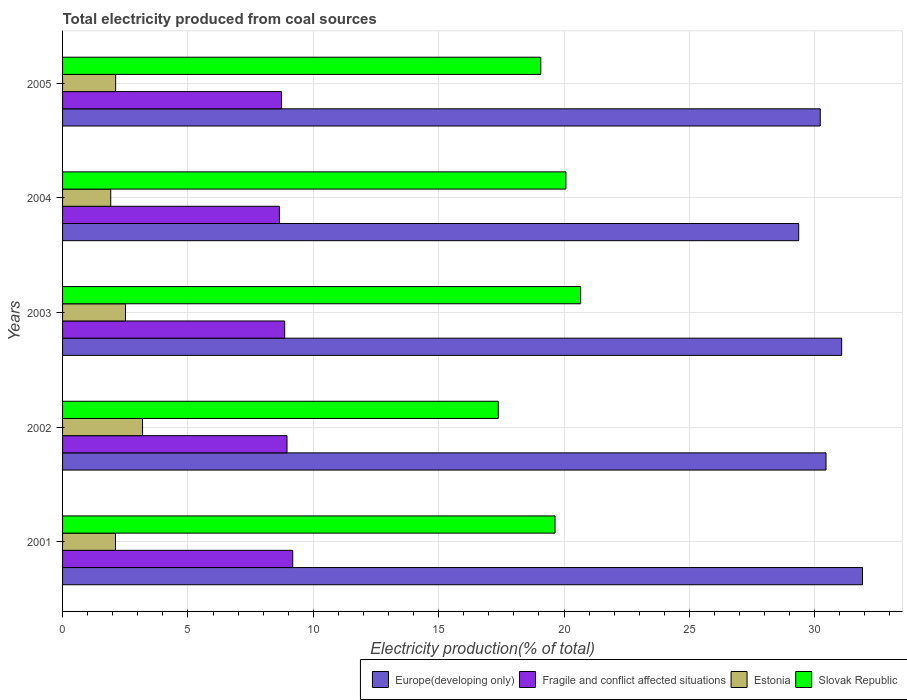How many different coloured bars are there?
Offer a very short reply. 4. How many groups of bars are there?
Ensure brevity in your answer.  5. Are the number of bars per tick equal to the number of legend labels?
Offer a very short reply. Yes. How many bars are there on the 3rd tick from the top?
Your response must be concise. 4. What is the total electricity produced in Slovak Republic in 2005?
Offer a very short reply. 19.07. Across all years, what is the maximum total electricity produced in Fragile and conflict affected situations?
Give a very brief answer. 9.18. Across all years, what is the minimum total electricity produced in Europe(developing only)?
Make the answer very short. 29.36. In which year was the total electricity produced in Estonia maximum?
Keep it short and to the point. 2002. In which year was the total electricity produced in Estonia minimum?
Keep it short and to the point. 2004. What is the total total electricity produced in Slovak Republic in the graph?
Offer a terse response. 96.83. What is the difference between the total electricity produced in Estonia in 2001 and that in 2004?
Provide a short and direct response. 0.19. What is the difference between the total electricity produced in Fragile and conflict affected situations in 2003 and the total electricity produced in Estonia in 2002?
Provide a short and direct response. 5.67. What is the average total electricity produced in Fragile and conflict affected situations per year?
Give a very brief answer. 8.87. In the year 2001, what is the difference between the total electricity produced in Estonia and total electricity produced in Slovak Republic?
Your answer should be compact. -17.53. In how many years, is the total electricity produced in Estonia greater than 29 %?
Your answer should be compact. 0. What is the ratio of the total electricity produced in Slovak Republic in 2004 to that in 2005?
Offer a very short reply. 1.05. Is the difference between the total electricity produced in Estonia in 2002 and 2005 greater than the difference between the total electricity produced in Slovak Republic in 2002 and 2005?
Provide a succinct answer. Yes. What is the difference between the highest and the second highest total electricity produced in Slovak Republic?
Offer a very short reply. 0.59. What is the difference between the highest and the lowest total electricity produced in Slovak Republic?
Offer a terse response. 3.29. Is it the case that in every year, the sum of the total electricity produced in Slovak Republic and total electricity produced in Estonia is greater than the sum of total electricity produced in Fragile and conflict affected situations and total electricity produced in Europe(developing only)?
Your answer should be compact. No. What does the 3rd bar from the top in 2003 represents?
Your answer should be very brief. Fragile and conflict affected situations. What does the 2nd bar from the bottom in 2001 represents?
Provide a succinct answer. Fragile and conflict affected situations. How many bars are there?
Offer a very short reply. 20. Are all the bars in the graph horizontal?
Ensure brevity in your answer.  Yes. Does the graph contain any zero values?
Your answer should be very brief. No. How many legend labels are there?
Offer a very short reply. 4. What is the title of the graph?
Your response must be concise. Total electricity produced from coal sources. What is the label or title of the Y-axis?
Your response must be concise. Years. What is the Electricity production(% of total) in Europe(developing only) in 2001?
Keep it short and to the point. 31.9. What is the Electricity production(% of total) of Fragile and conflict affected situations in 2001?
Your response must be concise. 9.18. What is the Electricity production(% of total) in Estonia in 2001?
Ensure brevity in your answer.  2.11. What is the Electricity production(% of total) of Slovak Republic in 2001?
Your answer should be compact. 19.64. What is the Electricity production(% of total) of Europe(developing only) in 2002?
Ensure brevity in your answer.  30.45. What is the Electricity production(% of total) of Fragile and conflict affected situations in 2002?
Give a very brief answer. 8.95. What is the Electricity production(% of total) in Estonia in 2002?
Make the answer very short. 3.19. What is the Electricity production(% of total) in Slovak Republic in 2002?
Your response must be concise. 17.38. What is the Electricity production(% of total) in Europe(developing only) in 2003?
Give a very brief answer. 31.07. What is the Electricity production(% of total) in Fragile and conflict affected situations in 2003?
Your answer should be very brief. 8.86. What is the Electricity production(% of total) in Estonia in 2003?
Make the answer very short. 2.51. What is the Electricity production(% of total) of Slovak Republic in 2003?
Give a very brief answer. 20.66. What is the Electricity production(% of total) of Europe(developing only) in 2004?
Your answer should be very brief. 29.36. What is the Electricity production(% of total) of Fragile and conflict affected situations in 2004?
Make the answer very short. 8.65. What is the Electricity production(% of total) in Estonia in 2004?
Ensure brevity in your answer.  1.92. What is the Electricity production(% of total) in Slovak Republic in 2004?
Offer a terse response. 20.08. What is the Electricity production(% of total) of Europe(developing only) in 2005?
Make the answer very short. 30.22. What is the Electricity production(% of total) in Fragile and conflict affected situations in 2005?
Offer a very short reply. 8.73. What is the Electricity production(% of total) of Estonia in 2005?
Offer a terse response. 2.12. What is the Electricity production(% of total) of Slovak Republic in 2005?
Provide a succinct answer. 19.07. Across all years, what is the maximum Electricity production(% of total) in Europe(developing only)?
Offer a very short reply. 31.9. Across all years, what is the maximum Electricity production(% of total) in Fragile and conflict affected situations?
Keep it short and to the point. 9.18. Across all years, what is the maximum Electricity production(% of total) in Estonia?
Your response must be concise. 3.19. Across all years, what is the maximum Electricity production(% of total) of Slovak Republic?
Offer a terse response. 20.66. Across all years, what is the minimum Electricity production(% of total) in Europe(developing only)?
Your answer should be very brief. 29.36. Across all years, what is the minimum Electricity production(% of total) of Fragile and conflict affected situations?
Offer a terse response. 8.65. Across all years, what is the minimum Electricity production(% of total) of Estonia?
Provide a succinct answer. 1.92. Across all years, what is the minimum Electricity production(% of total) in Slovak Republic?
Your answer should be compact. 17.38. What is the total Electricity production(% of total) in Europe(developing only) in the graph?
Ensure brevity in your answer.  153. What is the total Electricity production(% of total) of Fragile and conflict affected situations in the graph?
Provide a short and direct response. 44.37. What is the total Electricity production(% of total) of Estonia in the graph?
Provide a short and direct response. 11.85. What is the total Electricity production(% of total) in Slovak Republic in the graph?
Your response must be concise. 96.83. What is the difference between the Electricity production(% of total) in Europe(developing only) in 2001 and that in 2002?
Offer a very short reply. 1.45. What is the difference between the Electricity production(% of total) in Fragile and conflict affected situations in 2001 and that in 2002?
Provide a short and direct response. 0.23. What is the difference between the Electricity production(% of total) of Estonia in 2001 and that in 2002?
Your answer should be very brief. -1.08. What is the difference between the Electricity production(% of total) in Slovak Republic in 2001 and that in 2002?
Your answer should be very brief. 2.26. What is the difference between the Electricity production(% of total) of Europe(developing only) in 2001 and that in 2003?
Ensure brevity in your answer.  0.83. What is the difference between the Electricity production(% of total) in Fragile and conflict affected situations in 2001 and that in 2003?
Your response must be concise. 0.32. What is the difference between the Electricity production(% of total) of Estonia in 2001 and that in 2003?
Offer a terse response. -0.4. What is the difference between the Electricity production(% of total) of Slovak Republic in 2001 and that in 2003?
Provide a succinct answer. -1.02. What is the difference between the Electricity production(% of total) of Europe(developing only) in 2001 and that in 2004?
Make the answer very short. 2.54. What is the difference between the Electricity production(% of total) in Fragile and conflict affected situations in 2001 and that in 2004?
Your answer should be compact. 0.53. What is the difference between the Electricity production(% of total) of Estonia in 2001 and that in 2004?
Provide a short and direct response. 0.19. What is the difference between the Electricity production(% of total) in Slovak Republic in 2001 and that in 2004?
Give a very brief answer. -0.43. What is the difference between the Electricity production(% of total) in Europe(developing only) in 2001 and that in 2005?
Your answer should be very brief. 1.68. What is the difference between the Electricity production(% of total) in Fragile and conflict affected situations in 2001 and that in 2005?
Ensure brevity in your answer.  0.45. What is the difference between the Electricity production(% of total) in Estonia in 2001 and that in 2005?
Your response must be concise. -0.01. What is the difference between the Electricity production(% of total) of Slovak Republic in 2001 and that in 2005?
Offer a terse response. 0.57. What is the difference between the Electricity production(% of total) of Europe(developing only) in 2002 and that in 2003?
Provide a short and direct response. -0.62. What is the difference between the Electricity production(% of total) of Fragile and conflict affected situations in 2002 and that in 2003?
Ensure brevity in your answer.  0.09. What is the difference between the Electricity production(% of total) in Estonia in 2002 and that in 2003?
Keep it short and to the point. 0.68. What is the difference between the Electricity production(% of total) in Slovak Republic in 2002 and that in 2003?
Your answer should be compact. -3.29. What is the difference between the Electricity production(% of total) in Europe(developing only) in 2002 and that in 2004?
Offer a very short reply. 1.09. What is the difference between the Electricity production(% of total) of Fragile and conflict affected situations in 2002 and that in 2004?
Ensure brevity in your answer.  0.3. What is the difference between the Electricity production(% of total) of Estonia in 2002 and that in 2004?
Offer a very short reply. 1.27. What is the difference between the Electricity production(% of total) in Slovak Republic in 2002 and that in 2004?
Offer a very short reply. -2.7. What is the difference between the Electricity production(% of total) in Europe(developing only) in 2002 and that in 2005?
Provide a short and direct response. 0.23. What is the difference between the Electricity production(% of total) in Fragile and conflict affected situations in 2002 and that in 2005?
Your answer should be very brief. 0.22. What is the difference between the Electricity production(% of total) of Estonia in 2002 and that in 2005?
Keep it short and to the point. 1.07. What is the difference between the Electricity production(% of total) of Slovak Republic in 2002 and that in 2005?
Provide a succinct answer. -1.7. What is the difference between the Electricity production(% of total) in Europe(developing only) in 2003 and that in 2004?
Offer a very short reply. 1.71. What is the difference between the Electricity production(% of total) in Fragile and conflict affected situations in 2003 and that in 2004?
Offer a very short reply. 0.21. What is the difference between the Electricity production(% of total) in Estonia in 2003 and that in 2004?
Your response must be concise. 0.59. What is the difference between the Electricity production(% of total) of Slovak Republic in 2003 and that in 2004?
Your answer should be compact. 0.59. What is the difference between the Electricity production(% of total) in Europe(developing only) in 2003 and that in 2005?
Ensure brevity in your answer.  0.85. What is the difference between the Electricity production(% of total) in Fragile and conflict affected situations in 2003 and that in 2005?
Offer a very short reply. 0.13. What is the difference between the Electricity production(% of total) of Estonia in 2003 and that in 2005?
Keep it short and to the point. 0.39. What is the difference between the Electricity production(% of total) in Slovak Republic in 2003 and that in 2005?
Give a very brief answer. 1.59. What is the difference between the Electricity production(% of total) of Europe(developing only) in 2004 and that in 2005?
Provide a succinct answer. -0.86. What is the difference between the Electricity production(% of total) in Fragile and conflict affected situations in 2004 and that in 2005?
Offer a very short reply. -0.08. What is the difference between the Electricity production(% of total) in Estonia in 2004 and that in 2005?
Give a very brief answer. -0.2. What is the difference between the Electricity production(% of total) of Europe(developing only) in 2001 and the Electricity production(% of total) of Fragile and conflict affected situations in 2002?
Give a very brief answer. 22.95. What is the difference between the Electricity production(% of total) in Europe(developing only) in 2001 and the Electricity production(% of total) in Estonia in 2002?
Ensure brevity in your answer.  28.71. What is the difference between the Electricity production(% of total) in Europe(developing only) in 2001 and the Electricity production(% of total) in Slovak Republic in 2002?
Make the answer very short. 14.53. What is the difference between the Electricity production(% of total) in Fragile and conflict affected situations in 2001 and the Electricity production(% of total) in Estonia in 2002?
Ensure brevity in your answer.  5.99. What is the difference between the Electricity production(% of total) of Fragile and conflict affected situations in 2001 and the Electricity production(% of total) of Slovak Republic in 2002?
Your response must be concise. -8.2. What is the difference between the Electricity production(% of total) of Estonia in 2001 and the Electricity production(% of total) of Slovak Republic in 2002?
Provide a short and direct response. -15.27. What is the difference between the Electricity production(% of total) of Europe(developing only) in 2001 and the Electricity production(% of total) of Fragile and conflict affected situations in 2003?
Ensure brevity in your answer.  23.04. What is the difference between the Electricity production(% of total) of Europe(developing only) in 2001 and the Electricity production(% of total) of Estonia in 2003?
Provide a short and direct response. 29.39. What is the difference between the Electricity production(% of total) of Europe(developing only) in 2001 and the Electricity production(% of total) of Slovak Republic in 2003?
Give a very brief answer. 11.24. What is the difference between the Electricity production(% of total) of Fragile and conflict affected situations in 2001 and the Electricity production(% of total) of Estonia in 2003?
Offer a terse response. 6.67. What is the difference between the Electricity production(% of total) of Fragile and conflict affected situations in 2001 and the Electricity production(% of total) of Slovak Republic in 2003?
Give a very brief answer. -11.48. What is the difference between the Electricity production(% of total) of Estonia in 2001 and the Electricity production(% of total) of Slovak Republic in 2003?
Provide a succinct answer. -18.55. What is the difference between the Electricity production(% of total) in Europe(developing only) in 2001 and the Electricity production(% of total) in Fragile and conflict affected situations in 2004?
Your answer should be compact. 23.26. What is the difference between the Electricity production(% of total) in Europe(developing only) in 2001 and the Electricity production(% of total) in Estonia in 2004?
Offer a terse response. 29.98. What is the difference between the Electricity production(% of total) of Europe(developing only) in 2001 and the Electricity production(% of total) of Slovak Republic in 2004?
Your response must be concise. 11.83. What is the difference between the Electricity production(% of total) in Fragile and conflict affected situations in 2001 and the Electricity production(% of total) in Estonia in 2004?
Provide a succinct answer. 7.26. What is the difference between the Electricity production(% of total) in Fragile and conflict affected situations in 2001 and the Electricity production(% of total) in Slovak Republic in 2004?
Ensure brevity in your answer.  -10.9. What is the difference between the Electricity production(% of total) in Estonia in 2001 and the Electricity production(% of total) in Slovak Republic in 2004?
Make the answer very short. -17.97. What is the difference between the Electricity production(% of total) of Europe(developing only) in 2001 and the Electricity production(% of total) of Fragile and conflict affected situations in 2005?
Give a very brief answer. 23.17. What is the difference between the Electricity production(% of total) in Europe(developing only) in 2001 and the Electricity production(% of total) in Estonia in 2005?
Provide a short and direct response. 29.79. What is the difference between the Electricity production(% of total) of Europe(developing only) in 2001 and the Electricity production(% of total) of Slovak Republic in 2005?
Give a very brief answer. 12.83. What is the difference between the Electricity production(% of total) in Fragile and conflict affected situations in 2001 and the Electricity production(% of total) in Estonia in 2005?
Ensure brevity in your answer.  7.06. What is the difference between the Electricity production(% of total) of Fragile and conflict affected situations in 2001 and the Electricity production(% of total) of Slovak Republic in 2005?
Keep it short and to the point. -9.89. What is the difference between the Electricity production(% of total) of Estonia in 2001 and the Electricity production(% of total) of Slovak Republic in 2005?
Offer a terse response. -16.96. What is the difference between the Electricity production(% of total) of Europe(developing only) in 2002 and the Electricity production(% of total) of Fragile and conflict affected situations in 2003?
Your answer should be compact. 21.59. What is the difference between the Electricity production(% of total) in Europe(developing only) in 2002 and the Electricity production(% of total) in Estonia in 2003?
Make the answer very short. 27.94. What is the difference between the Electricity production(% of total) in Europe(developing only) in 2002 and the Electricity production(% of total) in Slovak Republic in 2003?
Your answer should be compact. 9.79. What is the difference between the Electricity production(% of total) in Fragile and conflict affected situations in 2002 and the Electricity production(% of total) in Estonia in 2003?
Your answer should be very brief. 6.44. What is the difference between the Electricity production(% of total) in Fragile and conflict affected situations in 2002 and the Electricity production(% of total) in Slovak Republic in 2003?
Make the answer very short. -11.71. What is the difference between the Electricity production(% of total) in Estonia in 2002 and the Electricity production(% of total) in Slovak Republic in 2003?
Offer a very short reply. -17.47. What is the difference between the Electricity production(% of total) of Europe(developing only) in 2002 and the Electricity production(% of total) of Fragile and conflict affected situations in 2004?
Ensure brevity in your answer.  21.8. What is the difference between the Electricity production(% of total) of Europe(developing only) in 2002 and the Electricity production(% of total) of Estonia in 2004?
Your answer should be compact. 28.53. What is the difference between the Electricity production(% of total) in Europe(developing only) in 2002 and the Electricity production(% of total) in Slovak Republic in 2004?
Your answer should be compact. 10.37. What is the difference between the Electricity production(% of total) in Fragile and conflict affected situations in 2002 and the Electricity production(% of total) in Estonia in 2004?
Make the answer very short. 7.03. What is the difference between the Electricity production(% of total) of Fragile and conflict affected situations in 2002 and the Electricity production(% of total) of Slovak Republic in 2004?
Provide a short and direct response. -11.12. What is the difference between the Electricity production(% of total) in Estonia in 2002 and the Electricity production(% of total) in Slovak Republic in 2004?
Your answer should be compact. -16.89. What is the difference between the Electricity production(% of total) of Europe(developing only) in 2002 and the Electricity production(% of total) of Fragile and conflict affected situations in 2005?
Give a very brief answer. 21.72. What is the difference between the Electricity production(% of total) in Europe(developing only) in 2002 and the Electricity production(% of total) in Estonia in 2005?
Keep it short and to the point. 28.33. What is the difference between the Electricity production(% of total) of Europe(developing only) in 2002 and the Electricity production(% of total) of Slovak Republic in 2005?
Offer a terse response. 11.38. What is the difference between the Electricity production(% of total) in Fragile and conflict affected situations in 2002 and the Electricity production(% of total) in Estonia in 2005?
Offer a very short reply. 6.83. What is the difference between the Electricity production(% of total) in Fragile and conflict affected situations in 2002 and the Electricity production(% of total) in Slovak Republic in 2005?
Offer a terse response. -10.12. What is the difference between the Electricity production(% of total) of Estonia in 2002 and the Electricity production(% of total) of Slovak Republic in 2005?
Offer a terse response. -15.88. What is the difference between the Electricity production(% of total) of Europe(developing only) in 2003 and the Electricity production(% of total) of Fragile and conflict affected situations in 2004?
Ensure brevity in your answer.  22.42. What is the difference between the Electricity production(% of total) of Europe(developing only) in 2003 and the Electricity production(% of total) of Estonia in 2004?
Keep it short and to the point. 29.15. What is the difference between the Electricity production(% of total) of Europe(developing only) in 2003 and the Electricity production(% of total) of Slovak Republic in 2004?
Your answer should be compact. 11. What is the difference between the Electricity production(% of total) in Fragile and conflict affected situations in 2003 and the Electricity production(% of total) in Estonia in 2004?
Offer a very short reply. 6.94. What is the difference between the Electricity production(% of total) of Fragile and conflict affected situations in 2003 and the Electricity production(% of total) of Slovak Republic in 2004?
Make the answer very short. -11.22. What is the difference between the Electricity production(% of total) in Estonia in 2003 and the Electricity production(% of total) in Slovak Republic in 2004?
Ensure brevity in your answer.  -17.57. What is the difference between the Electricity production(% of total) of Europe(developing only) in 2003 and the Electricity production(% of total) of Fragile and conflict affected situations in 2005?
Offer a very short reply. 22.34. What is the difference between the Electricity production(% of total) in Europe(developing only) in 2003 and the Electricity production(% of total) in Estonia in 2005?
Provide a succinct answer. 28.96. What is the difference between the Electricity production(% of total) in Europe(developing only) in 2003 and the Electricity production(% of total) in Slovak Republic in 2005?
Offer a terse response. 12. What is the difference between the Electricity production(% of total) of Fragile and conflict affected situations in 2003 and the Electricity production(% of total) of Estonia in 2005?
Make the answer very short. 6.74. What is the difference between the Electricity production(% of total) in Fragile and conflict affected situations in 2003 and the Electricity production(% of total) in Slovak Republic in 2005?
Make the answer very short. -10.21. What is the difference between the Electricity production(% of total) in Estonia in 2003 and the Electricity production(% of total) in Slovak Republic in 2005?
Ensure brevity in your answer.  -16.56. What is the difference between the Electricity production(% of total) of Europe(developing only) in 2004 and the Electricity production(% of total) of Fragile and conflict affected situations in 2005?
Give a very brief answer. 20.63. What is the difference between the Electricity production(% of total) in Europe(developing only) in 2004 and the Electricity production(% of total) in Estonia in 2005?
Your answer should be very brief. 27.24. What is the difference between the Electricity production(% of total) of Europe(developing only) in 2004 and the Electricity production(% of total) of Slovak Republic in 2005?
Your answer should be very brief. 10.29. What is the difference between the Electricity production(% of total) of Fragile and conflict affected situations in 2004 and the Electricity production(% of total) of Estonia in 2005?
Keep it short and to the point. 6.53. What is the difference between the Electricity production(% of total) of Fragile and conflict affected situations in 2004 and the Electricity production(% of total) of Slovak Republic in 2005?
Keep it short and to the point. -10.43. What is the difference between the Electricity production(% of total) in Estonia in 2004 and the Electricity production(% of total) in Slovak Republic in 2005?
Give a very brief answer. -17.15. What is the average Electricity production(% of total) in Europe(developing only) per year?
Keep it short and to the point. 30.6. What is the average Electricity production(% of total) in Fragile and conflict affected situations per year?
Provide a succinct answer. 8.87. What is the average Electricity production(% of total) of Estonia per year?
Offer a terse response. 2.37. What is the average Electricity production(% of total) of Slovak Republic per year?
Offer a terse response. 19.37. In the year 2001, what is the difference between the Electricity production(% of total) of Europe(developing only) and Electricity production(% of total) of Fragile and conflict affected situations?
Give a very brief answer. 22.72. In the year 2001, what is the difference between the Electricity production(% of total) in Europe(developing only) and Electricity production(% of total) in Estonia?
Offer a very short reply. 29.79. In the year 2001, what is the difference between the Electricity production(% of total) of Europe(developing only) and Electricity production(% of total) of Slovak Republic?
Give a very brief answer. 12.26. In the year 2001, what is the difference between the Electricity production(% of total) in Fragile and conflict affected situations and Electricity production(% of total) in Estonia?
Keep it short and to the point. 7.07. In the year 2001, what is the difference between the Electricity production(% of total) in Fragile and conflict affected situations and Electricity production(% of total) in Slovak Republic?
Ensure brevity in your answer.  -10.46. In the year 2001, what is the difference between the Electricity production(% of total) of Estonia and Electricity production(% of total) of Slovak Republic?
Your answer should be compact. -17.53. In the year 2002, what is the difference between the Electricity production(% of total) in Europe(developing only) and Electricity production(% of total) in Fragile and conflict affected situations?
Ensure brevity in your answer.  21.5. In the year 2002, what is the difference between the Electricity production(% of total) in Europe(developing only) and Electricity production(% of total) in Estonia?
Your answer should be compact. 27.26. In the year 2002, what is the difference between the Electricity production(% of total) in Europe(developing only) and Electricity production(% of total) in Slovak Republic?
Ensure brevity in your answer.  13.07. In the year 2002, what is the difference between the Electricity production(% of total) of Fragile and conflict affected situations and Electricity production(% of total) of Estonia?
Ensure brevity in your answer.  5.76. In the year 2002, what is the difference between the Electricity production(% of total) in Fragile and conflict affected situations and Electricity production(% of total) in Slovak Republic?
Your answer should be compact. -8.43. In the year 2002, what is the difference between the Electricity production(% of total) of Estonia and Electricity production(% of total) of Slovak Republic?
Provide a short and direct response. -14.19. In the year 2003, what is the difference between the Electricity production(% of total) in Europe(developing only) and Electricity production(% of total) in Fragile and conflict affected situations?
Offer a terse response. 22.21. In the year 2003, what is the difference between the Electricity production(% of total) in Europe(developing only) and Electricity production(% of total) in Estonia?
Offer a very short reply. 28.56. In the year 2003, what is the difference between the Electricity production(% of total) of Europe(developing only) and Electricity production(% of total) of Slovak Republic?
Your answer should be very brief. 10.41. In the year 2003, what is the difference between the Electricity production(% of total) of Fragile and conflict affected situations and Electricity production(% of total) of Estonia?
Your answer should be compact. 6.35. In the year 2003, what is the difference between the Electricity production(% of total) of Fragile and conflict affected situations and Electricity production(% of total) of Slovak Republic?
Offer a terse response. -11.8. In the year 2003, what is the difference between the Electricity production(% of total) in Estonia and Electricity production(% of total) in Slovak Republic?
Provide a short and direct response. -18.15. In the year 2004, what is the difference between the Electricity production(% of total) of Europe(developing only) and Electricity production(% of total) of Fragile and conflict affected situations?
Give a very brief answer. 20.71. In the year 2004, what is the difference between the Electricity production(% of total) in Europe(developing only) and Electricity production(% of total) in Estonia?
Ensure brevity in your answer.  27.44. In the year 2004, what is the difference between the Electricity production(% of total) in Europe(developing only) and Electricity production(% of total) in Slovak Republic?
Provide a succinct answer. 9.28. In the year 2004, what is the difference between the Electricity production(% of total) of Fragile and conflict affected situations and Electricity production(% of total) of Estonia?
Give a very brief answer. 6.73. In the year 2004, what is the difference between the Electricity production(% of total) in Fragile and conflict affected situations and Electricity production(% of total) in Slovak Republic?
Ensure brevity in your answer.  -11.43. In the year 2004, what is the difference between the Electricity production(% of total) in Estonia and Electricity production(% of total) in Slovak Republic?
Your response must be concise. -18.15. In the year 2005, what is the difference between the Electricity production(% of total) of Europe(developing only) and Electricity production(% of total) of Fragile and conflict affected situations?
Your answer should be compact. 21.49. In the year 2005, what is the difference between the Electricity production(% of total) in Europe(developing only) and Electricity production(% of total) in Estonia?
Your answer should be very brief. 28.1. In the year 2005, what is the difference between the Electricity production(% of total) in Europe(developing only) and Electricity production(% of total) in Slovak Republic?
Your answer should be compact. 11.15. In the year 2005, what is the difference between the Electricity production(% of total) of Fragile and conflict affected situations and Electricity production(% of total) of Estonia?
Provide a short and direct response. 6.62. In the year 2005, what is the difference between the Electricity production(% of total) in Fragile and conflict affected situations and Electricity production(% of total) in Slovak Republic?
Offer a terse response. -10.34. In the year 2005, what is the difference between the Electricity production(% of total) in Estonia and Electricity production(% of total) in Slovak Republic?
Offer a terse response. -16.96. What is the ratio of the Electricity production(% of total) in Europe(developing only) in 2001 to that in 2002?
Keep it short and to the point. 1.05. What is the ratio of the Electricity production(% of total) of Fragile and conflict affected situations in 2001 to that in 2002?
Your answer should be compact. 1.03. What is the ratio of the Electricity production(% of total) in Estonia in 2001 to that in 2002?
Your answer should be compact. 0.66. What is the ratio of the Electricity production(% of total) in Slovak Republic in 2001 to that in 2002?
Provide a succinct answer. 1.13. What is the ratio of the Electricity production(% of total) in Europe(developing only) in 2001 to that in 2003?
Offer a very short reply. 1.03. What is the ratio of the Electricity production(% of total) in Fragile and conflict affected situations in 2001 to that in 2003?
Provide a succinct answer. 1.04. What is the ratio of the Electricity production(% of total) of Estonia in 2001 to that in 2003?
Offer a very short reply. 0.84. What is the ratio of the Electricity production(% of total) of Slovak Republic in 2001 to that in 2003?
Offer a very short reply. 0.95. What is the ratio of the Electricity production(% of total) of Europe(developing only) in 2001 to that in 2004?
Provide a succinct answer. 1.09. What is the ratio of the Electricity production(% of total) of Fragile and conflict affected situations in 2001 to that in 2004?
Your answer should be compact. 1.06. What is the ratio of the Electricity production(% of total) in Estonia in 2001 to that in 2004?
Provide a succinct answer. 1.1. What is the ratio of the Electricity production(% of total) in Slovak Republic in 2001 to that in 2004?
Your response must be concise. 0.98. What is the ratio of the Electricity production(% of total) of Europe(developing only) in 2001 to that in 2005?
Offer a very short reply. 1.06. What is the ratio of the Electricity production(% of total) of Fragile and conflict affected situations in 2001 to that in 2005?
Ensure brevity in your answer.  1.05. What is the ratio of the Electricity production(% of total) of Estonia in 2001 to that in 2005?
Make the answer very short. 1. What is the ratio of the Electricity production(% of total) of Slovak Republic in 2001 to that in 2005?
Your response must be concise. 1.03. What is the ratio of the Electricity production(% of total) of Europe(developing only) in 2002 to that in 2003?
Provide a short and direct response. 0.98. What is the ratio of the Electricity production(% of total) of Fragile and conflict affected situations in 2002 to that in 2003?
Offer a terse response. 1.01. What is the ratio of the Electricity production(% of total) in Estonia in 2002 to that in 2003?
Your answer should be compact. 1.27. What is the ratio of the Electricity production(% of total) of Slovak Republic in 2002 to that in 2003?
Offer a very short reply. 0.84. What is the ratio of the Electricity production(% of total) in Europe(developing only) in 2002 to that in 2004?
Keep it short and to the point. 1.04. What is the ratio of the Electricity production(% of total) in Fragile and conflict affected situations in 2002 to that in 2004?
Offer a terse response. 1.04. What is the ratio of the Electricity production(% of total) of Estonia in 2002 to that in 2004?
Make the answer very short. 1.66. What is the ratio of the Electricity production(% of total) of Slovak Republic in 2002 to that in 2004?
Ensure brevity in your answer.  0.87. What is the ratio of the Electricity production(% of total) of Europe(developing only) in 2002 to that in 2005?
Give a very brief answer. 1.01. What is the ratio of the Electricity production(% of total) of Fragile and conflict affected situations in 2002 to that in 2005?
Offer a terse response. 1.03. What is the ratio of the Electricity production(% of total) of Estonia in 2002 to that in 2005?
Provide a short and direct response. 1.51. What is the ratio of the Electricity production(% of total) of Slovak Republic in 2002 to that in 2005?
Offer a terse response. 0.91. What is the ratio of the Electricity production(% of total) of Europe(developing only) in 2003 to that in 2004?
Ensure brevity in your answer.  1.06. What is the ratio of the Electricity production(% of total) of Fragile and conflict affected situations in 2003 to that in 2004?
Your answer should be very brief. 1.02. What is the ratio of the Electricity production(% of total) of Estonia in 2003 to that in 2004?
Give a very brief answer. 1.31. What is the ratio of the Electricity production(% of total) in Slovak Republic in 2003 to that in 2004?
Your answer should be compact. 1.03. What is the ratio of the Electricity production(% of total) in Europe(developing only) in 2003 to that in 2005?
Provide a short and direct response. 1.03. What is the ratio of the Electricity production(% of total) of Fragile and conflict affected situations in 2003 to that in 2005?
Provide a short and direct response. 1.01. What is the ratio of the Electricity production(% of total) of Estonia in 2003 to that in 2005?
Ensure brevity in your answer.  1.19. What is the ratio of the Electricity production(% of total) of Slovak Republic in 2003 to that in 2005?
Ensure brevity in your answer.  1.08. What is the ratio of the Electricity production(% of total) in Europe(developing only) in 2004 to that in 2005?
Offer a very short reply. 0.97. What is the ratio of the Electricity production(% of total) of Estonia in 2004 to that in 2005?
Offer a very short reply. 0.91. What is the ratio of the Electricity production(% of total) of Slovak Republic in 2004 to that in 2005?
Offer a terse response. 1.05. What is the difference between the highest and the second highest Electricity production(% of total) of Europe(developing only)?
Offer a very short reply. 0.83. What is the difference between the highest and the second highest Electricity production(% of total) of Fragile and conflict affected situations?
Offer a terse response. 0.23. What is the difference between the highest and the second highest Electricity production(% of total) in Estonia?
Provide a succinct answer. 0.68. What is the difference between the highest and the second highest Electricity production(% of total) in Slovak Republic?
Provide a short and direct response. 0.59. What is the difference between the highest and the lowest Electricity production(% of total) in Europe(developing only)?
Make the answer very short. 2.54. What is the difference between the highest and the lowest Electricity production(% of total) in Fragile and conflict affected situations?
Your answer should be compact. 0.53. What is the difference between the highest and the lowest Electricity production(% of total) of Estonia?
Your response must be concise. 1.27. What is the difference between the highest and the lowest Electricity production(% of total) in Slovak Republic?
Your answer should be compact. 3.29. 